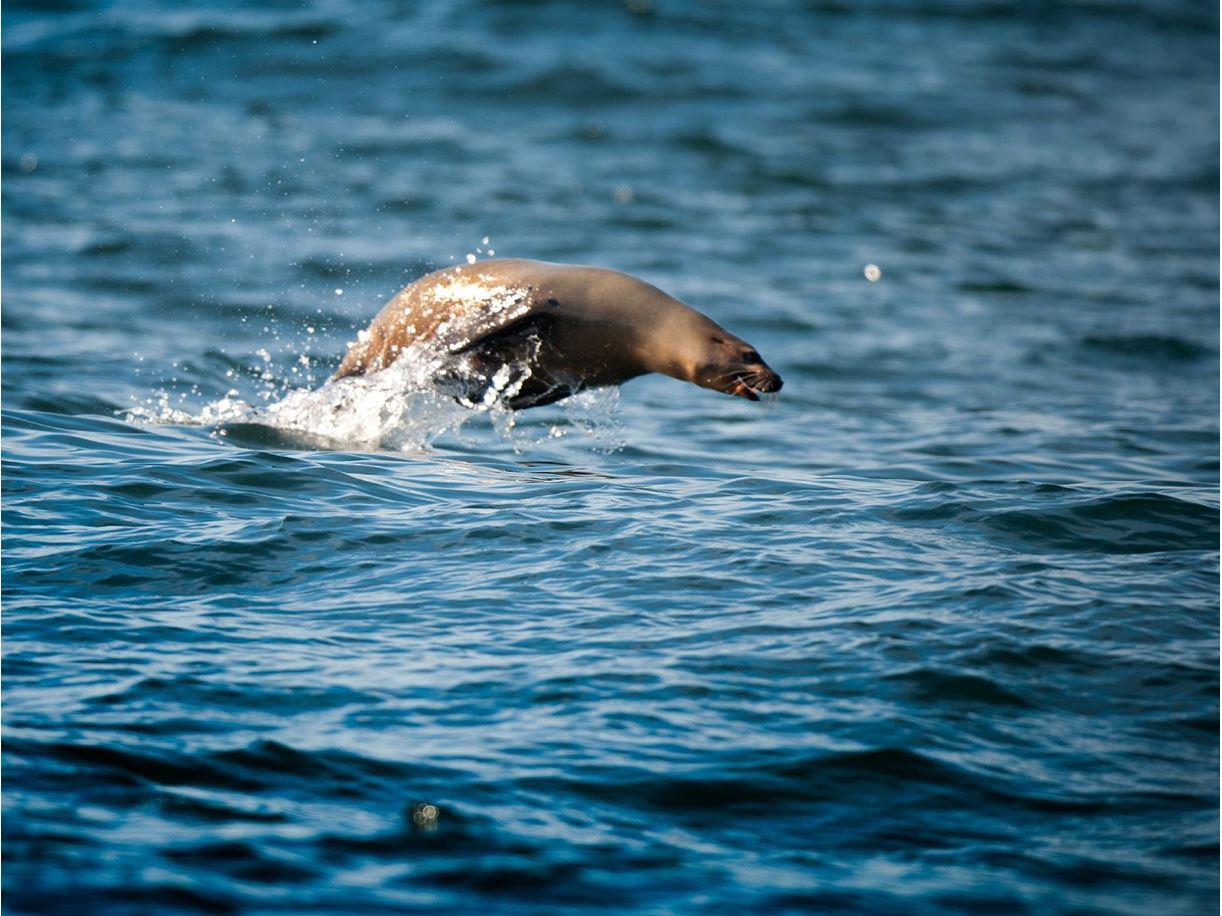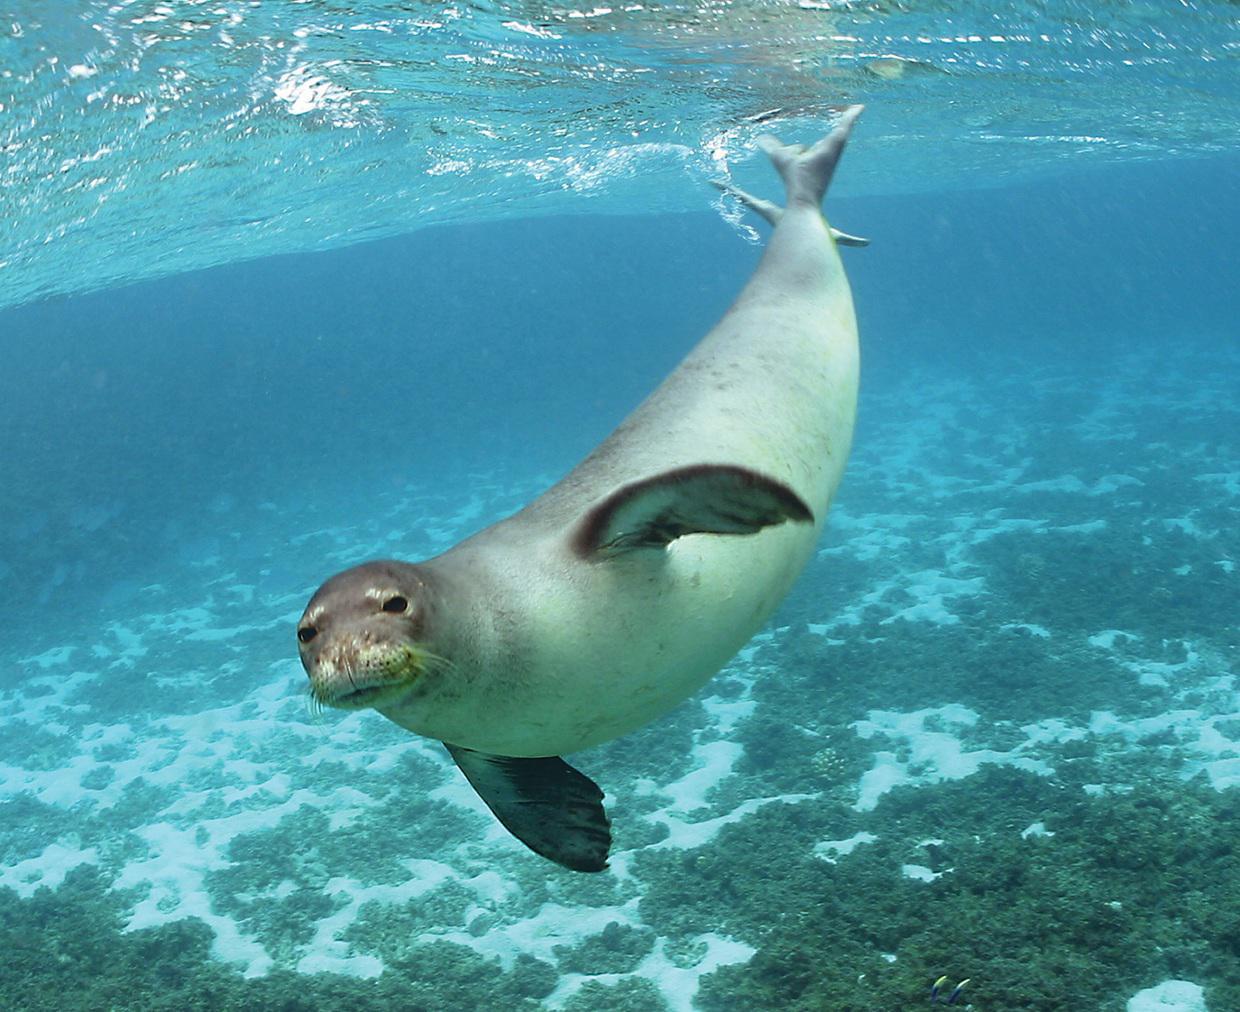The first image is the image on the left, the second image is the image on the right. Given the left and right images, does the statement "There is at least one seal resting on a solid surface" hold true? Answer yes or no. No. 